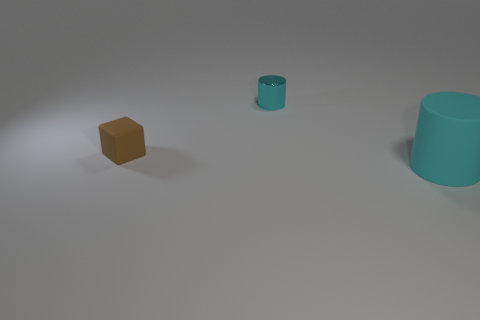What is the tiny cyan cylinder made of?
Your response must be concise. Metal. Do the block and the tiny metal object behind the block have the same color?
Offer a terse response. No. What number of tiny cyan shiny things are in front of the metallic thing?
Give a very brief answer. 0. Are there fewer tiny blocks that are to the left of the tiny cube than small matte spheres?
Provide a succinct answer. No. What is the color of the small metallic cylinder?
Your response must be concise. Cyan. Is the color of the matte object to the left of the cyan metallic cylinder the same as the big rubber cylinder?
Offer a very short reply. No. What color is the other rubber thing that is the same shape as the tiny cyan object?
Keep it short and to the point. Cyan. How many tiny objects are metallic objects or red rubber spheres?
Make the answer very short. 1. There is a cyan object behind the large cyan cylinder; how big is it?
Provide a short and direct response. Small. Is there a metal ball that has the same color as the small matte thing?
Your answer should be very brief. No. 